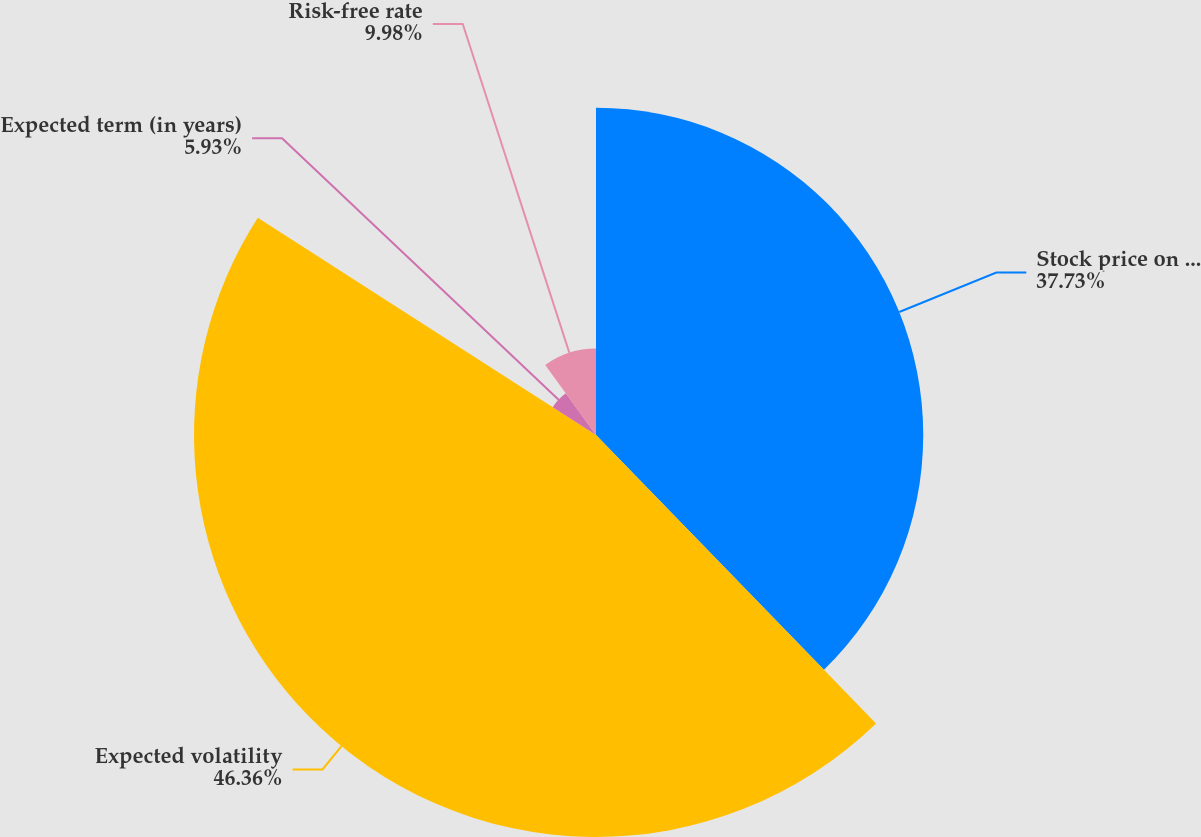Convert chart. <chart><loc_0><loc_0><loc_500><loc_500><pie_chart><fcel>Stock price on date of grant<fcel>Expected volatility<fcel>Expected term (in years)<fcel>Risk-free rate<nl><fcel>37.73%<fcel>46.35%<fcel>5.93%<fcel>9.98%<nl></chart> 